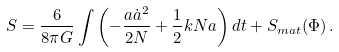Convert formula to latex. <formula><loc_0><loc_0><loc_500><loc_500>S = \frac { 6 } { 8 \pi G } \int { \left ( - \frac { a { \dot { a } } ^ { 2 } } { 2 N } + \frac { 1 } { 2 } k N a \right ) d t } + S _ { m a t } ( \Phi ) \, .</formula> 